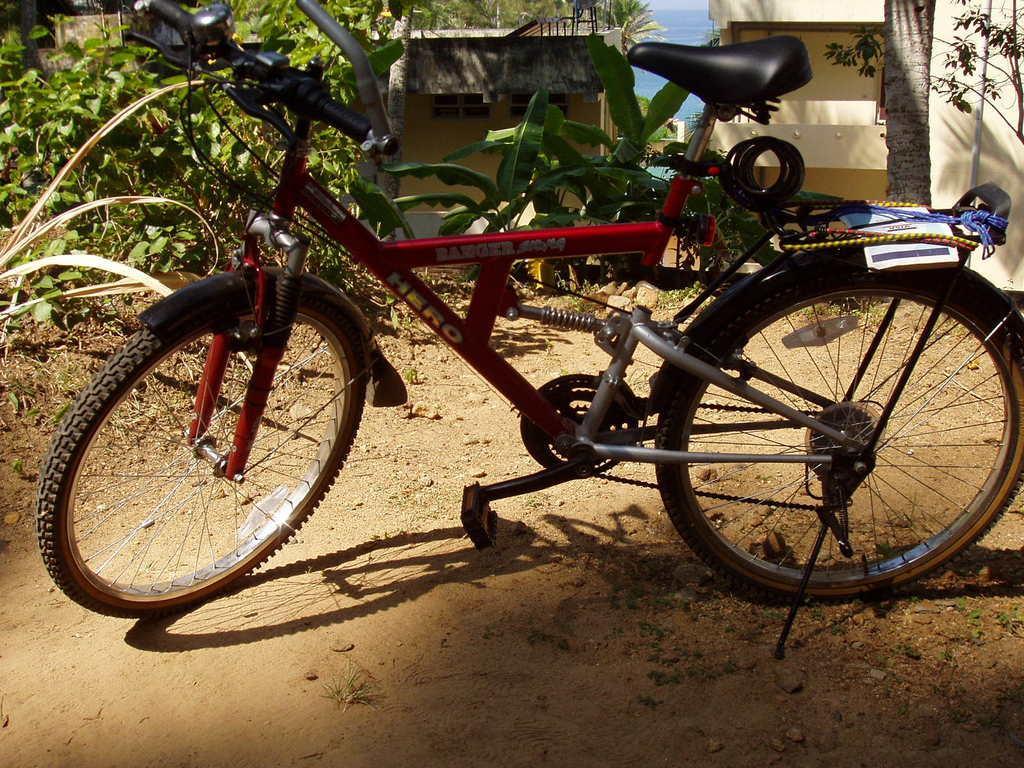Please provide a concise description of this image. In the picture we can see the bicycle, which is parked on the mud surface and behind it, we can see some plants and in the background, we can see a tree branch and two houses and in the middle of it we can see a part of the sky which is blue in color. 